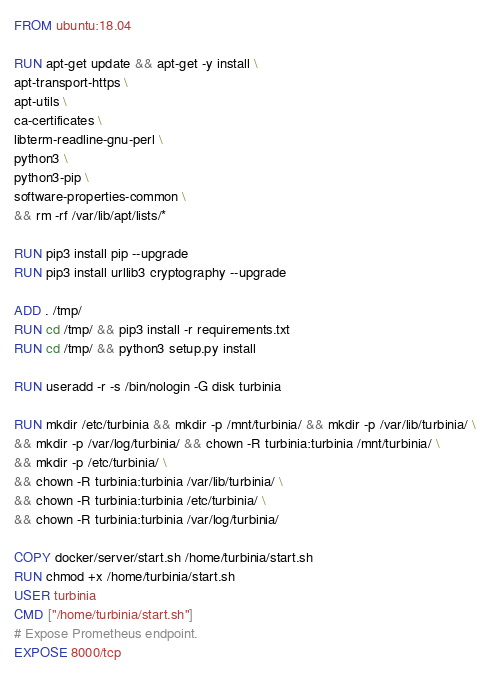<code> <loc_0><loc_0><loc_500><loc_500><_Dockerfile_>FROM ubuntu:18.04

RUN apt-get update && apt-get -y install \
apt-transport-https \
apt-utils \
ca-certificates \
libterm-readline-gnu-perl \
python3 \
python3-pip \
software-properties-common \
&& rm -rf /var/lib/apt/lists/*

RUN pip3 install pip --upgrade
RUN pip3 install urllib3 cryptography --upgrade

ADD . /tmp/
RUN cd /tmp/ && pip3 install -r requirements.txt
RUN cd /tmp/ && python3 setup.py install

RUN useradd -r -s /bin/nologin -G disk turbinia

RUN mkdir /etc/turbinia && mkdir -p /mnt/turbinia/ && mkdir -p /var/lib/turbinia/ \
&& mkdir -p /var/log/turbinia/ && chown -R turbinia:turbinia /mnt/turbinia/ \
&& mkdir -p /etc/turbinia/ \
&& chown -R turbinia:turbinia /var/lib/turbinia/ \
&& chown -R turbinia:turbinia /etc/turbinia/ \
&& chown -R turbinia:turbinia /var/log/turbinia/

COPY docker/server/start.sh /home/turbinia/start.sh
RUN chmod +x /home/turbinia/start.sh
USER turbinia
CMD ["/home/turbinia/start.sh"]
# Expose Prometheus endpoint.
EXPOSE 8000/tcp
</code> 